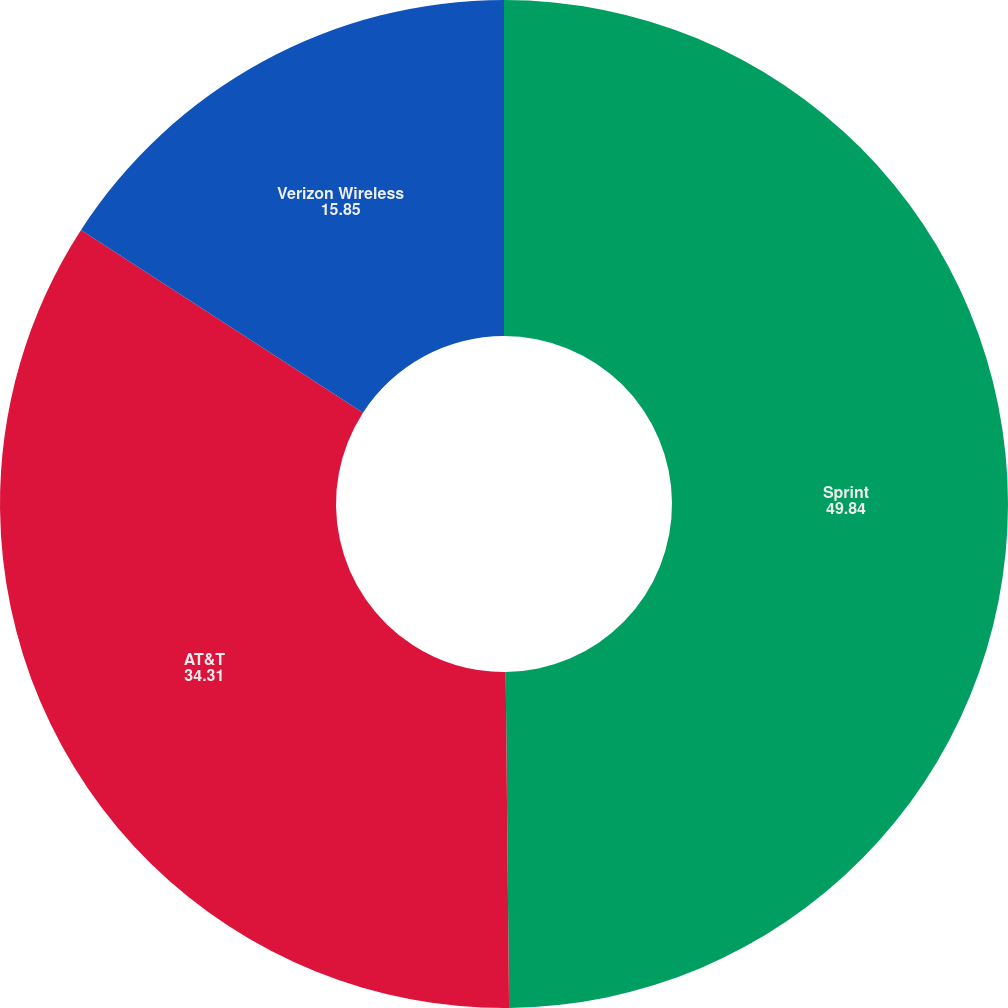Convert chart. <chart><loc_0><loc_0><loc_500><loc_500><pie_chart><fcel>Sprint<fcel>AT&T<fcel>Verizon Wireless<nl><fcel>49.84%<fcel>34.31%<fcel>15.85%<nl></chart> 